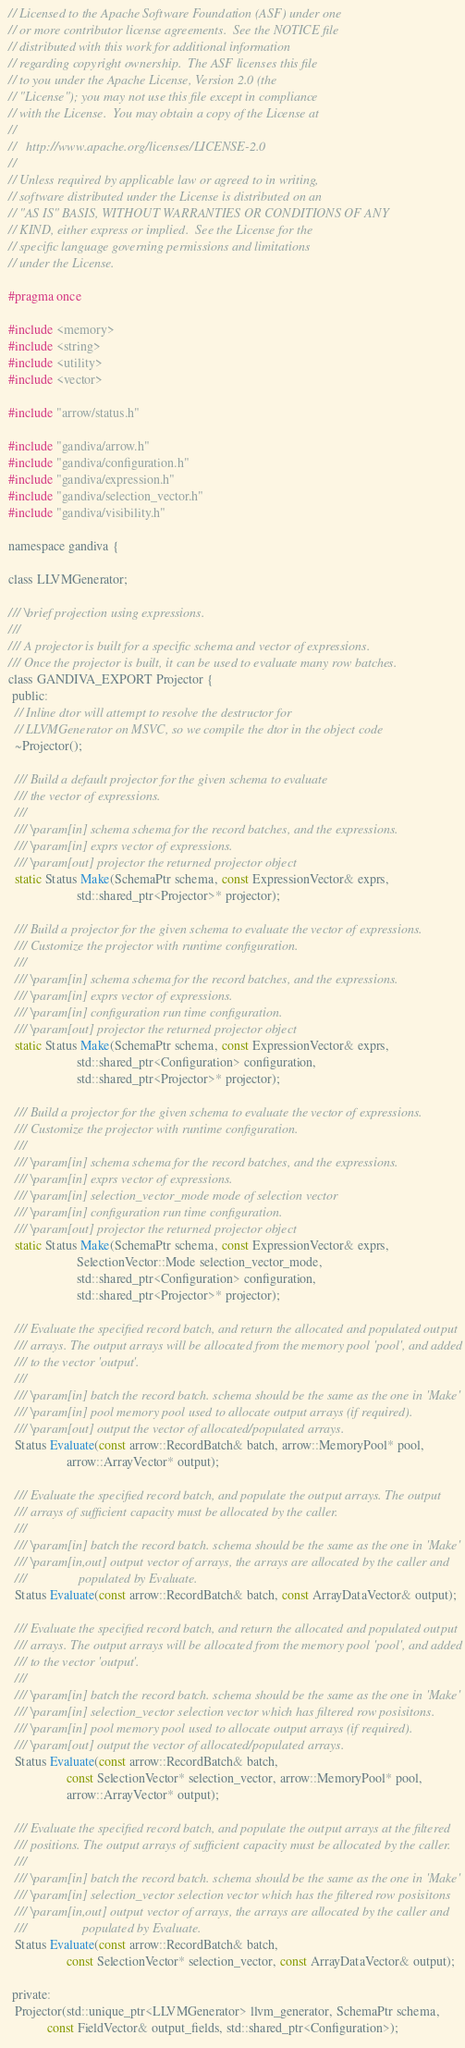<code> <loc_0><loc_0><loc_500><loc_500><_C_>// Licensed to the Apache Software Foundation (ASF) under one
// or more contributor license agreements.  See the NOTICE file
// distributed with this work for additional information
// regarding copyright ownership.  The ASF licenses this file
// to you under the Apache License, Version 2.0 (the
// "License"); you may not use this file except in compliance
// with the License.  You may obtain a copy of the License at
//
//   http://www.apache.org/licenses/LICENSE-2.0
//
// Unless required by applicable law or agreed to in writing,
// software distributed under the License is distributed on an
// "AS IS" BASIS, WITHOUT WARRANTIES OR CONDITIONS OF ANY
// KIND, either express or implied.  See the License for the
// specific language governing permissions and limitations
// under the License.

#pragma once

#include <memory>
#include <string>
#include <utility>
#include <vector>

#include "arrow/status.h"

#include "gandiva/arrow.h"
#include "gandiva/configuration.h"
#include "gandiva/expression.h"
#include "gandiva/selection_vector.h"
#include "gandiva/visibility.h"

namespace gandiva {

class LLVMGenerator;

/// \brief projection using expressions.
///
/// A projector is built for a specific schema and vector of expressions.
/// Once the projector is built, it can be used to evaluate many row batches.
class GANDIVA_EXPORT Projector {
 public:
  // Inline dtor will attempt to resolve the destructor for
  // LLVMGenerator on MSVC, so we compile the dtor in the object code
  ~Projector();

  /// Build a default projector for the given schema to evaluate
  /// the vector of expressions.
  ///
  /// \param[in] schema schema for the record batches, and the expressions.
  /// \param[in] exprs vector of expressions.
  /// \param[out] projector the returned projector object
  static Status Make(SchemaPtr schema, const ExpressionVector& exprs,
                     std::shared_ptr<Projector>* projector);

  /// Build a projector for the given schema to evaluate the vector of expressions.
  /// Customize the projector with runtime configuration.
  ///
  /// \param[in] schema schema for the record batches, and the expressions.
  /// \param[in] exprs vector of expressions.
  /// \param[in] configuration run time configuration.
  /// \param[out] projector the returned projector object
  static Status Make(SchemaPtr schema, const ExpressionVector& exprs,
                     std::shared_ptr<Configuration> configuration,
                     std::shared_ptr<Projector>* projector);

  /// Build a projector for the given schema to evaluate the vector of expressions.
  /// Customize the projector with runtime configuration.
  ///
  /// \param[in] schema schema for the record batches, and the expressions.
  /// \param[in] exprs vector of expressions.
  /// \param[in] selection_vector_mode mode of selection vector
  /// \param[in] configuration run time configuration.
  /// \param[out] projector the returned projector object
  static Status Make(SchemaPtr schema, const ExpressionVector& exprs,
                     SelectionVector::Mode selection_vector_mode,
                     std::shared_ptr<Configuration> configuration,
                     std::shared_ptr<Projector>* projector);

  /// Evaluate the specified record batch, and return the allocated and populated output
  /// arrays. The output arrays will be allocated from the memory pool 'pool', and added
  /// to the vector 'output'.
  ///
  /// \param[in] batch the record batch. schema should be the same as the one in 'Make'
  /// \param[in] pool memory pool used to allocate output arrays (if required).
  /// \param[out] output the vector of allocated/populated arrays.
  Status Evaluate(const arrow::RecordBatch& batch, arrow::MemoryPool* pool,
                  arrow::ArrayVector* output);

  /// Evaluate the specified record batch, and populate the output arrays. The output
  /// arrays of sufficient capacity must be allocated by the caller.
  ///
  /// \param[in] batch the record batch. schema should be the same as the one in 'Make'
  /// \param[in,out] output vector of arrays, the arrays are allocated by the caller and
  ///                populated by Evaluate.
  Status Evaluate(const arrow::RecordBatch& batch, const ArrayDataVector& output);

  /// Evaluate the specified record batch, and return the allocated and populated output
  /// arrays. The output arrays will be allocated from the memory pool 'pool', and added
  /// to the vector 'output'.
  ///
  /// \param[in] batch the record batch. schema should be the same as the one in 'Make'
  /// \param[in] selection_vector selection vector which has filtered row posisitons.
  /// \param[in] pool memory pool used to allocate output arrays (if required).
  /// \param[out] output the vector of allocated/populated arrays.
  Status Evaluate(const arrow::RecordBatch& batch,
                  const SelectionVector* selection_vector, arrow::MemoryPool* pool,
                  arrow::ArrayVector* output);

  /// Evaluate the specified record batch, and populate the output arrays at the filtered
  /// positions. The output arrays of sufficient capacity must be allocated by the caller.
  ///
  /// \param[in] batch the record batch. schema should be the same as the one in 'Make'
  /// \param[in] selection_vector selection vector which has the filtered row posisitons
  /// \param[in,out] output vector of arrays, the arrays are allocated by the caller and
  ///                 populated by Evaluate.
  Status Evaluate(const arrow::RecordBatch& batch,
                  const SelectionVector* selection_vector, const ArrayDataVector& output);

 private:
  Projector(std::unique_ptr<LLVMGenerator> llvm_generator, SchemaPtr schema,
            const FieldVector& output_fields, std::shared_ptr<Configuration>);
</code> 